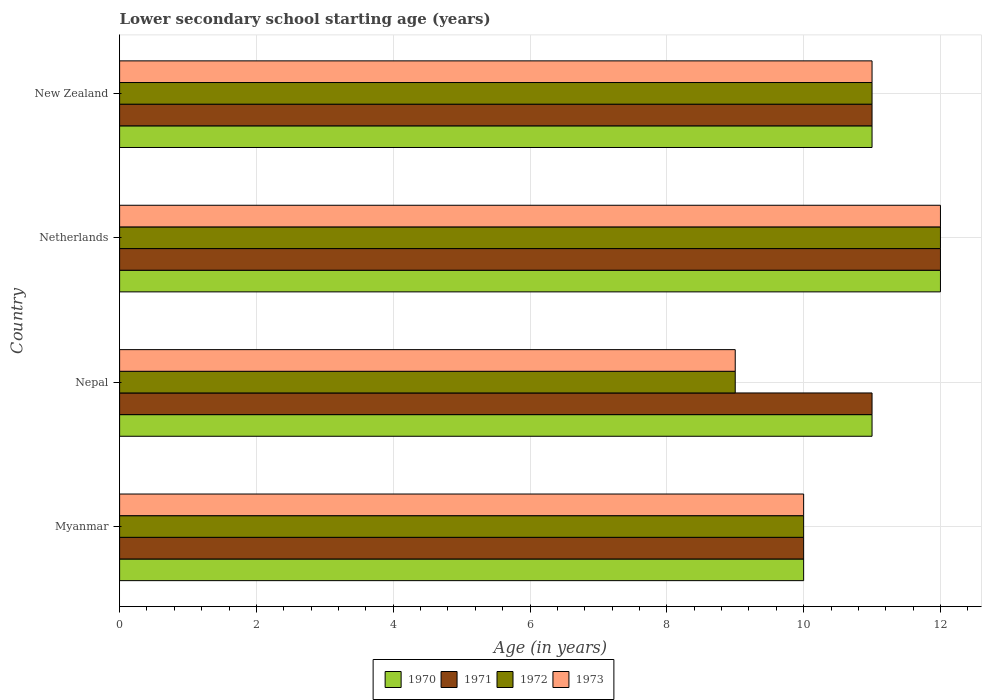How many different coloured bars are there?
Make the answer very short. 4. Are the number of bars per tick equal to the number of legend labels?
Your answer should be very brief. Yes. What is the label of the 4th group of bars from the top?
Offer a very short reply. Myanmar. In how many cases, is the number of bars for a given country not equal to the number of legend labels?
Offer a terse response. 0. What is the lower secondary school starting age of children in 1971 in Myanmar?
Provide a succinct answer. 10. In which country was the lower secondary school starting age of children in 1972 minimum?
Provide a short and direct response. Nepal. What is the difference between the lower secondary school starting age of children in 1972 and lower secondary school starting age of children in 1973 in New Zealand?
Ensure brevity in your answer.  0. In how many countries, is the lower secondary school starting age of children in 1970 greater than 8.8 years?
Give a very brief answer. 4. What is the ratio of the lower secondary school starting age of children in 1971 in Nepal to that in Netherlands?
Keep it short and to the point. 0.92. Is the lower secondary school starting age of children in 1973 in Netherlands less than that in New Zealand?
Make the answer very short. No. Is the difference between the lower secondary school starting age of children in 1972 in Myanmar and Netherlands greater than the difference between the lower secondary school starting age of children in 1973 in Myanmar and Netherlands?
Your answer should be compact. No. What is the difference between the highest and the second highest lower secondary school starting age of children in 1971?
Offer a terse response. 1. What is the difference between the highest and the lowest lower secondary school starting age of children in 1973?
Make the answer very short. 3. In how many countries, is the lower secondary school starting age of children in 1970 greater than the average lower secondary school starting age of children in 1970 taken over all countries?
Offer a terse response. 1. Is it the case that in every country, the sum of the lower secondary school starting age of children in 1971 and lower secondary school starting age of children in 1970 is greater than the sum of lower secondary school starting age of children in 1972 and lower secondary school starting age of children in 1973?
Keep it short and to the point. No. What does the 3rd bar from the top in Myanmar represents?
Your response must be concise. 1971. What does the 3rd bar from the bottom in Nepal represents?
Provide a short and direct response. 1972. Is it the case that in every country, the sum of the lower secondary school starting age of children in 1971 and lower secondary school starting age of children in 1973 is greater than the lower secondary school starting age of children in 1972?
Your answer should be very brief. Yes. How many bars are there?
Give a very brief answer. 16. Are all the bars in the graph horizontal?
Provide a succinct answer. Yes. Are the values on the major ticks of X-axis written in scientific E-notation?
Offer a very short reply. No. Does the graph contain any zero values?
Your answer should be very brief. No. Does the graph contain grids?
Your answer should be compact. Yes. Where does the legend appear in the graph?
Provide a succinct answer. Bottom center. How many legend labels are there?
Offer a very short reply. 4. What is the title of the graph?
Keep it short and to the point. Lower secondary school starting age (years). Does "1968" appear as one of the legend labels in the graph?
Provide a short and direct response. No. What is the label or title of the X-axis?
Make the answer very short. Age (in years). What is the label or title of the Y-axis?
Keep it short and to the point. Country. What is the Age (in years) of 1970 in Myanmar?
Your response must be concise. 10. What is the Age (in years) in 1971 in Nepal?
Ensure brevity in your answer.  11. What is the Age (in years) in 1972 in Nepal?
Give a very brief answer. 9. What is the Age (in years) of 1971 in Netherlands?
Provide a succinct answer. 12. What is the Age (in years) of 1972 in Netherlands?
Offer a very short reply. 12. What is the Age (in years) of 1970 in New Zealand?
Provide a succinct answer. 11. Across all countries, what is the maximum Age (in years) of 1970?
Offer a very short reply. 12. Across all countries, what is the maximum Age (in years) in 1971?
Provide a succinct answer. 12. Across all countries, what is the maximum Age (in years) of 1972?
Make the answer very short. 12. Across all countries, what is the minimum Age (in years) of 1970?
Offer a very short reply. 10. Across all countries, what is the minimum Age (in years) in 1971?
Ensure brevity in your answer.  10. Across all countries, what is the minimum Age (in years) of 1972?
Provide a succinct answer. 9. Across all countries, what is the minimum Age (in years) in 1973?
Provide a short and direct response. 9. What is the total Age (in years) of 1970 in the graph?
Make the answer very short. 44. What is the total Age (in years) in 1972 in the graph?
Your answer should be very brief. 42. What is the difference between the Age (in years) in 1970 in Myanmar and that in Nepal?
Your answer should be compact. -1. What is the difference between the Age (in years) in 1971 in Myanmar and that in Nepal?
Offer a very short reply. -1. What is the difference between the Age (in years) in 1972 in Myanmar and that in Nepal?
Keep it short and to the point. 1. What is the difference between the Age (in years) in 1973 in Myanmar and that in Nepal?
Offer a very short reply. 1. What is the difference between the Age (in years) in 1970 in Myanmar and that in Netherlands?
Ensure brevity in your answer.  -2. What is the difference between the Age (in years) of 1970 in Myanmar and that in New Zealand?
Ensure brevity in your answer.  -1. What is the difference between the Age (in years) in 1972 in Myanmar and that in New Zealand?
Make the answer very short. -1. What is the difference between the Age (in years) in 1973 in Myanmar and that in New Zealand?
Provide a succinct answer. -1. What is the difference between the Age (in years) in 1973 in Nepal and that in Netherlands?
Ensure brevity in your answer.  -3. What is the difference between the Age (in years) of 1970 in Nepal and that in New Zealand?
Keep it short and to the point. 0. What is the difference between the Age (in years) of 1970 in Netherlands and that in New Zealand?
Offer a very short reply. 1. What is the difference between the Age (in years) of 1971 in Netherlands and that in New Zealand?
Offer a very short reply. 1. What is the difference between the Age (in years) of 1972 in Netherlands and that in New Zealand?
Offer a very short reply. 1. What is the difference between the Age (in years) in 1971 in Myanmar and the Age (in years) in 1972 in Nepal?
Your response must be concise. 1. What is the difference between the Age (in years) in 1971 in Myanmar and the Age (in years) in 1973 in Nepal?
Your answer should be very brief. 1. What is the difference between the Age (in years) of 1970 in Myanmar and the Age (in years) of 1971 in Netherlands?
Your answer should be compact. -2. What is the difference between the Age (in years) of 1971 in Myanmar and the Age (in years) of 1972 in Netherlands?
Offer a terse response. -2. What is the difference between the Age (in years) of 1971 in Myanmar and the Age (in years) of 1973 in Netherlands?
Keep it short and to the point. -2. What is the difference between the Age (in years) of 1970 in Myanmar and the Age (in years) of 1971 in New Zealand?
Offer a terse response. -1. What is the difference between the Age (in years) of 1970 in Myanmar and the Age (in years) of 1972 in New Zealand?
Provide a short and direct response. -1. What is the difference between the Age (in years) of 1971 in Myanmar and the Age (in years) of 1972 in New Zealand?
Your response must be concise. -1. What is the difference between the Age (in years) in 1970 in Nepal and the Age (in years) in 1972 in Netherlands?
Give a very brief answer. -1. What is the difference between the Age (in years) in 1970 in Nepal and the Age (in years) in 1973 in Netherlands?
Your answer should be compact. -1. What is the difference between the Age (in years) in 1971 in Nepal and the Age (in years) in 1973 in Netherlands?
Keep it short and to the point. -1. What is the difference between the Age (in years) of 1970 in Nepal and the Age (in years) of 1972 in New Zealand?
Your answer should be compact. 0. What is the difference between the Age (in years) in 1970 in Nepal and the Age (in years) in 1973 in New Zealand?
Ensure brevity in your answer.  0. What is the difference between the Age (in years) in 1972 in Nepal and the Age (in years) in 1973 in New Zealand?
Make the answer very short. -2. What is the difference between the Age (in years) in 1971 in Netherlands and the Age (in years) in 1972 in New Zealand?
Give a very brief answer. 1. What is the difference between the Age (in years) of 1971 in Netherlands and the Age (in years) of 1973 in New Zealand?
Keep it short and to the point. 1. What is the average Age (in years) of 1970 per country?
Make the answer very short. 11. What is the average Age (in years) of 1971 per country?
Provide a succinct answer. 11. What is the difference between the Age (in years) in 1970 and Age (in years) in 1971 in Myanmar?
Your response must be concise. 0. What is the difference between the Age (in years) of 1970 and Age (in years) of 1972 in Myanmar?
Ensure brevity in your answer.  0. What is the difference between the Age (in years) of 1970 and Age (in years) of 1973 in Myanmar?
Offer a terse response. 0. What is the difference between the Age (in years) of 1970 and Age (in years) of 1972 in Nepal?
Your answer should be compact. 2. What is the difference between the Age (in years) in 1970 and Age (in years) in 1973 in Nepal?
Provide a succinct answer. 2. What is the difference between the Age (in years) in 1971 and Age (in years) in 1972 in Nepal?
Your response must be concise. 2. What is the difference between the Age (in years) of 1972 and Age (in years) of 1973 in Nepal?
Make the answer very short. 0. What is the difference between the Age (in years) of 1970 and Age (in years) of 1972 in Netherlands?
Give a very brief answer. 0. What is the difference between the Age (in years) in 1971 and Age (in years) in 1973 in Netherlands?
Offer a very short reply. 0. What is the difference between the Age (in years) in 1972 and Age (in years) in 1973 in Netherlands?
Your response must be concise. 0. What is the difference between the Age (in years) in 1971 and Age (in years) in 1972 in New Zealand?
Make the answer very short. 0. What is the difference between the Age (in years) in 1971 and Age (in years) in 1973 in New Zealand?
Your answer should be very brief. 0. What is the ratio of the Age (in years) in 1970 in Myanmar to that in Nepal?
Offer a terse response. 0.91. What is the ratio of the Age (in years) in 1971 in Myanmar to that in Netherlands?
Offer a terse response. 0.83. What is the ratio of the Age (in years) in 1972 in Myanmar to that in Netherlands?
Provide a short and direct response. 0.83. What is the ratio of the Age (in years) in 1971 in Myanmar to that in New Zealand?
Give a very brief answer. 0.91. What is the ratio of the Age (in years) in 1972 in Myanmar to that in New Zealand?
Offer a very short reply. 0.91. What is the ratio of the Age (in years) in 1970 in Nepal to that in Netherlands?
Your answer should be compact. 0.92. What is the ratio of the Age (in years) of 1971 in Nepal to that in Netherlands?
Keep it short and to the point. 0.92. What is the ratio of the Age (in years) in 1973 in Nepal to that in Netherlands?
Provide a succinct answer. 0.75. What is the ratio of the Age (in years) of 1972 in Nepal to that in New Zealand?
Provide a short and direct response. 0.82. What is the ratio of the Age (in years) in 1973 in Nepal to that in New Zealand?
Offer a very short reply. 0.82. What is the ratio of the Age (in years) of 1970 in Netherlands to that in New Zealand?
Give a very brief answer. 1.09. What is the ratio of the Age (in years) of 1971 in Netherlands to that in New Zealand?
Provide a succinct answer. 1.09. What is the difference between the highest and the second highest Age (in years) of 1970?
Your answer should be compact. 1. What is the difference between the highest and the second highest Age (in years) in 1973?
Give a very brief answer. 1. What is the difference between the highest and the lowest Age (in years) in 1970?
Your response must be concise. 2. What is the difference between the highest and the lowest Age (in years) of 1973?
Keep it short and to the point. 3. 